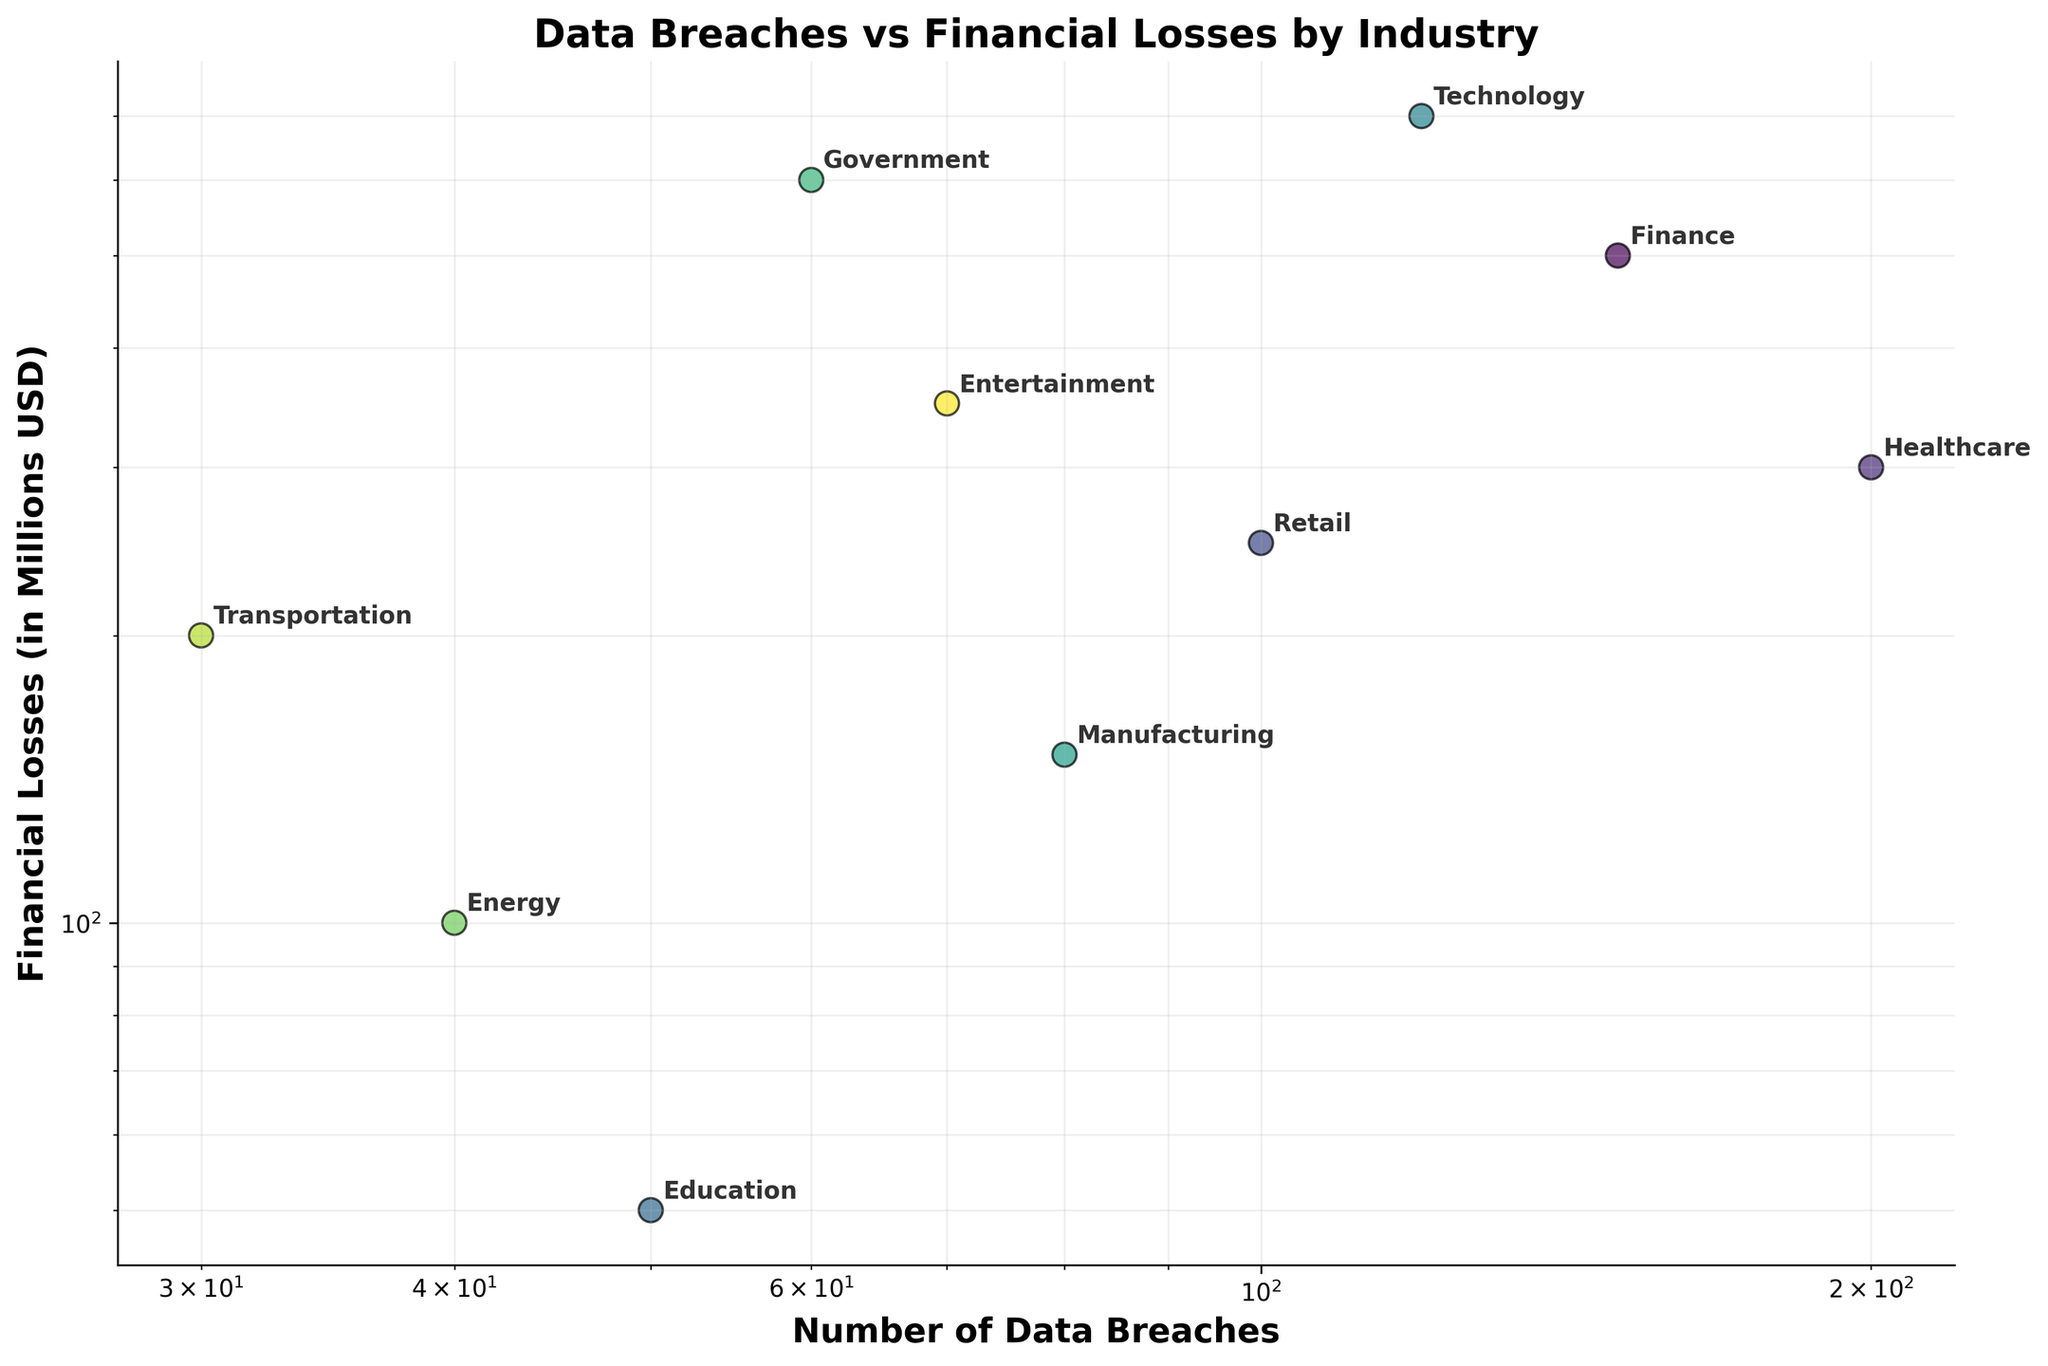what is the title of the plot? The title of the plot is typically displayed at the top and in larger font size compared to other text elements. Observing the top of the figure, you will see the title clearly labeled.
Answer: Data Breaches vs Financial Losses by Industry How many industries are plotted in the figure? You count the number of unique points in the scatter plot, each labeled with a different industry name. By observing all the labels next to each point, you can count the total number of unique industries presented.
Answer: 10 Which industry has the highest financial loss? According to the y-axis (Financial Losses in Millions USD), find the point that is furthest up. The label next to this point will indicate the industry with the highest financial loss.
Answer: Technology Which industry has the fewest data breaches? According to the x-axis (Number of Data Breaches), find the point that is furthest to the left. The label next to this point will indicate the industry with the fewest data breaches.
Answer: Transportation What is the color scheme used for the plot points? The color scheme can be identified by the gradient of colors applied to the points in the scatter plot. By observing the colors of the points, we determine that a specific colormap has been used, which in this case is a sequential color scheme resembling viridis (typically involving gradients of purple, blue, green, and yellow).
Answer: Viridis Which industry has the highest financial loss among those with less than 100 data breaches? Look for points on the scatter plot to the left of the '100' mark on the x-axis and identify the one with the highest y-axis value. The label next to this point will indicate the corresponding industry.
Answer: Government How do the financial losses in the retail industry compare to the healthcare industry? Locate the points labeled 'Retail' and 'Healthcare' on the scatter plot. Compare their positions on the y-axis to evaluate which one is higher. Higher position means higher financial losses.
Answer: Healthcare > Retail What can you infer about the relationship between data breaches and financial losses? Given that both axes are on a log scale and observing the spread and location of the points, we see if there is a general trend (e.g., upward, downward, or no clear trend).
Answer: Generally, more data breaches correlate with higher financial losses How does the financial loss in the finance industry compare to the government industry? Identifying the points labeled 'Finance' and 'Government', compare their locations on the y-axis to see which is higher.
Answer: Government > Finance Is the financial loss in the entertainment industry more aligned with the finance industry or the retail industry? Check the y-axis values for 'Entertainment', 'Finance', and 'Retail'. Determine which two industries have closer y-axis values indicating financial losses.
Answer: Entertainment is closer to Finance 